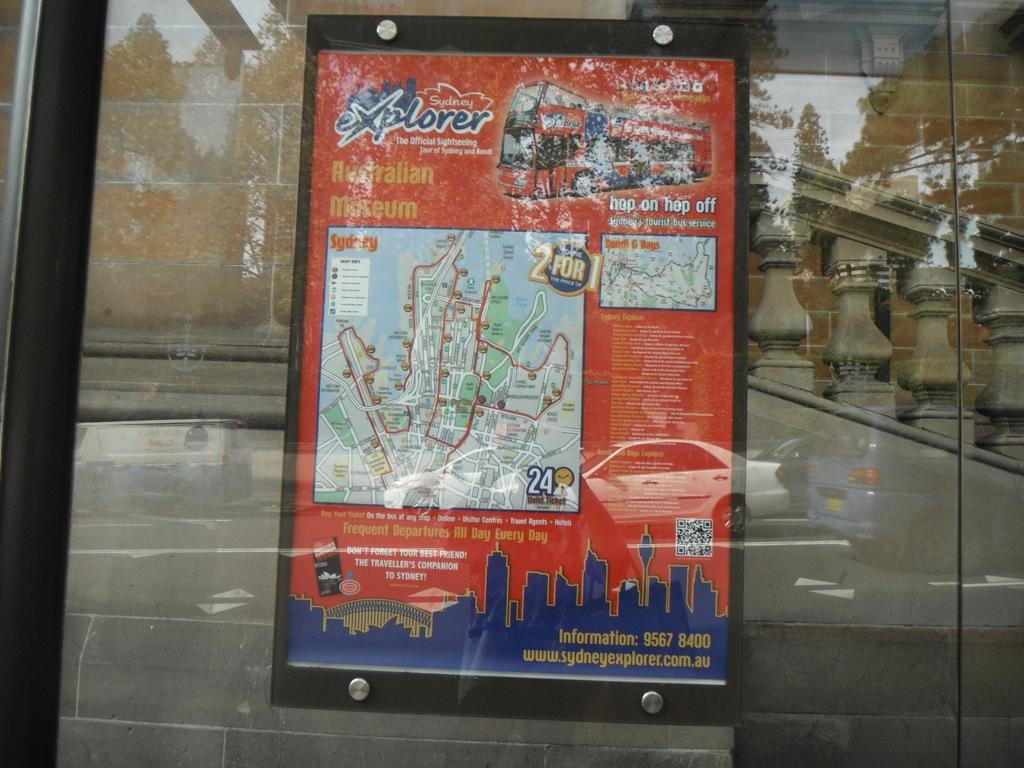What museum is mentioned?
Offer a terse response. Australian. What is the website?
Your answer should be compact. Www.sydneyexplorer.com.au. 